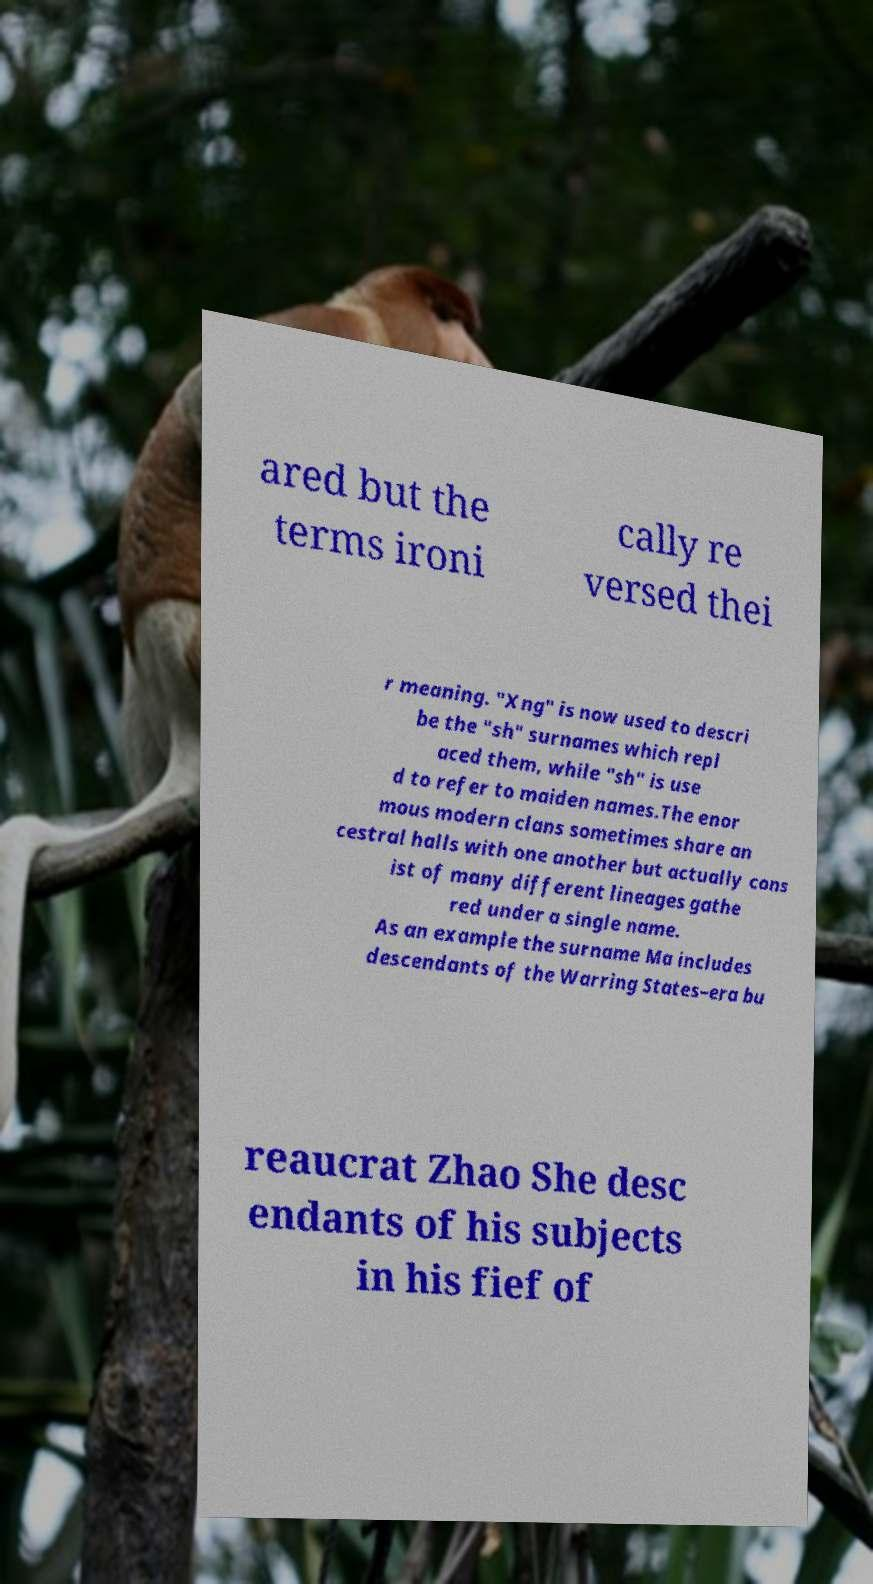Please read and relay the text visible in this image. What does it say? ared but the terms ironi cally re versed thei r meaning. "Xng" is now used to descri be the "sh" surnames which repl aced them, while "sh" is use d to refer to maiden names.The enor mous modern clans sometimes share an cestral halls with one another but actually cons ist of many different lineages gathe red under a single name. As an example the surname Ma includes descendants of the Warring States–era bu reaucrat Zhao She desc endants of his subjects in his fief of 